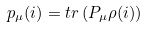Convert formula to latex. <formula><loc_0><loc_0><loc_500><loc_500>p _ { \mu } ( i ) = t r \left ( P _ { \mu } \rho ( i ) \right )</formula> 